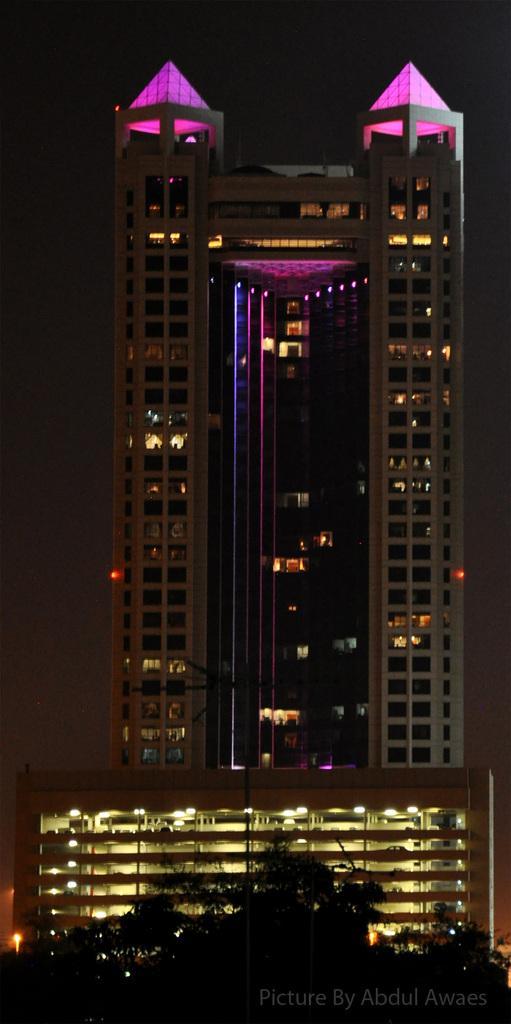Please provide a concise description of this image. in the foreground of the picture there are trees. In the center of the picture there is a building and a skyscraper. 